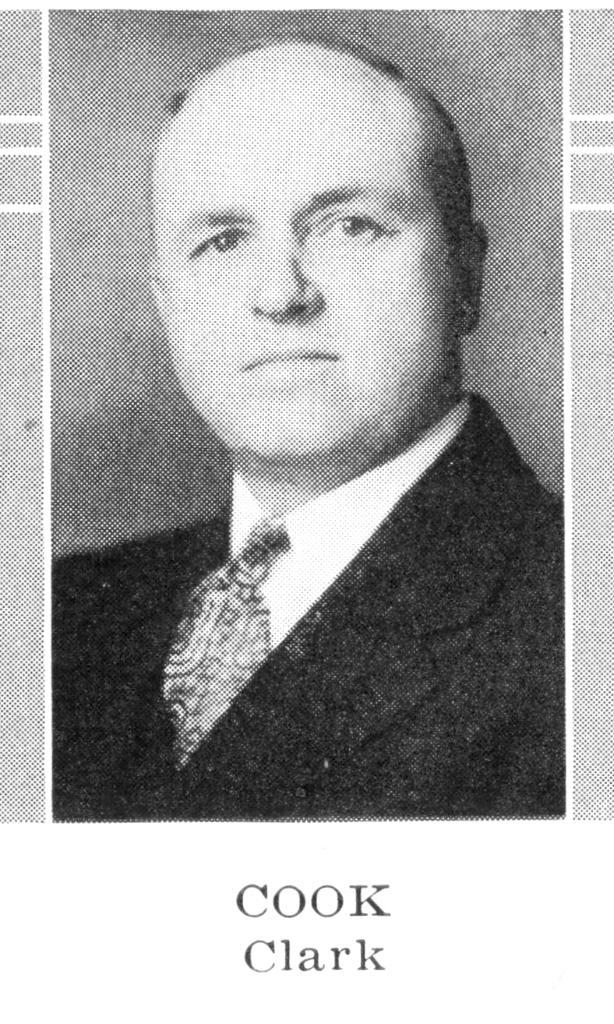What is the main subject of the image? The main subject of the image is a picture of a man. What type of clothing is the man wearing? The man is wearing a blazer, a shirt, and a tie. What else can be seen in the image besides the man? There is text visible in the image. What type of substance is the man using to polish the plastic in the image? There is no substance, plastic, or polishing activity present in the image. 